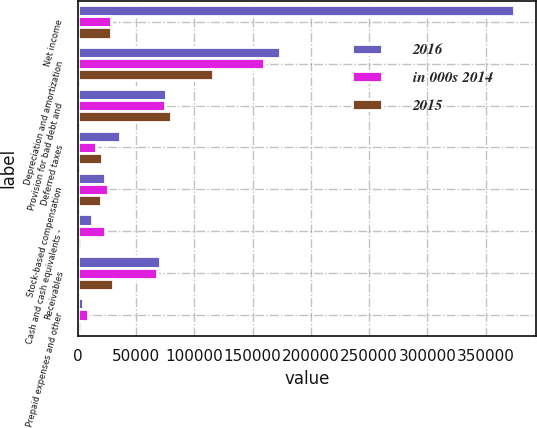<chart> <loc_0><loc_0><loc_500><loc_500><stacked_bar_chart><ecel><fcel>Net income<fcel>Depreciation and amortization<fcel>Provision for bad debt and<fcel>Deferred taxes<fcel>Stock-based compensation<fcel>Cash and cash equivalents -<fcel>Receivables<fcel>Prepaid expenses and other<nl><fcel>2016<fcel>374267<fcel>173598<fcel>75395<fcel>36276<fcel>23540<fcel>12159<fcel>70721<fcel>4321<nl><fcel>in 000s 2014<fcel>28222<fcel>159804<fcel>74993<fcel>15502<fcel>26068<fcel>23252<fcel>68109<fcel>8542<nl><fcel>2015<fcel>28222<fcel>115604<fcel>80007<fcel>20958<fcel>20058<fcel>2522<fcel>30376<fcel>2293<nl></chart> 